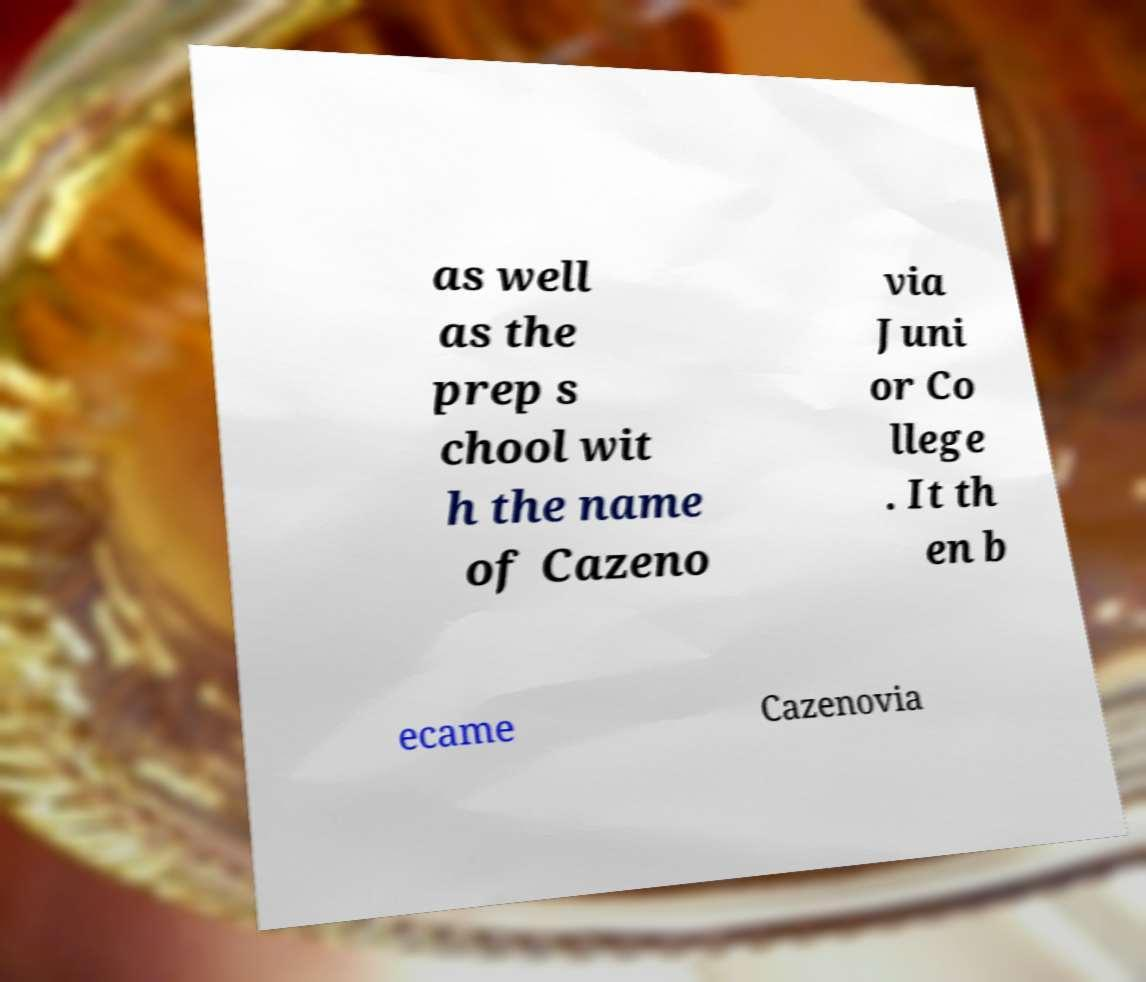There's text embedded in this image that I need extracted. Can you transcribe it verbatim? as well as the prep s chool wit h the name of Cazeno via Juni or Co llege . It th en b ecame Cazenovia 